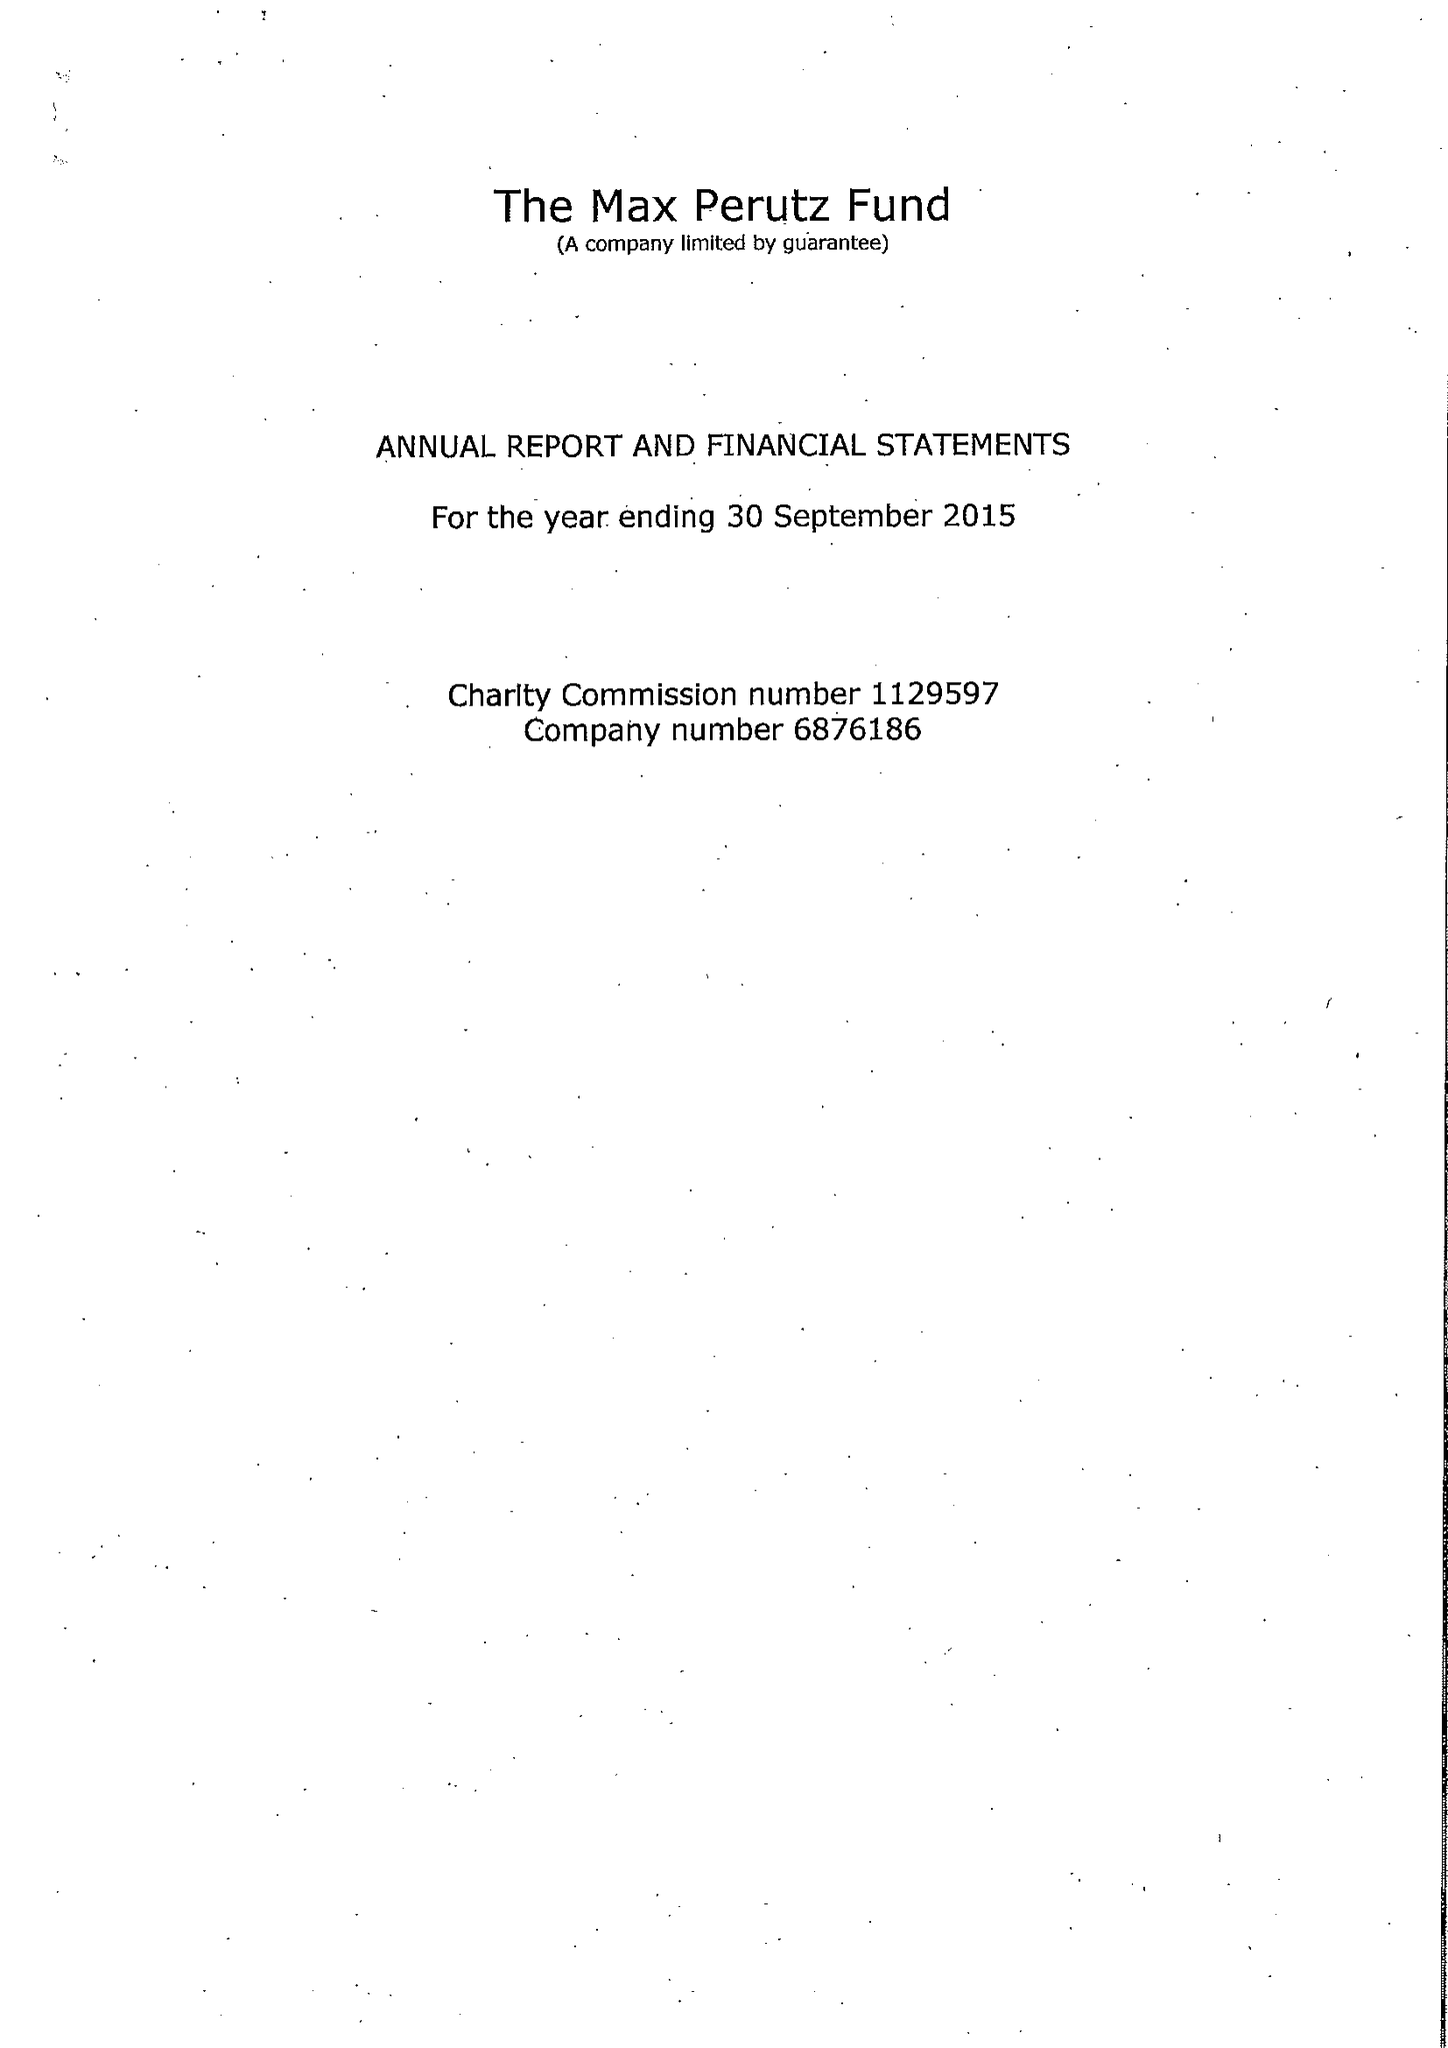What is the value for the address__postcode?
Answer the question using a single word or phrase. CB2 0QH 